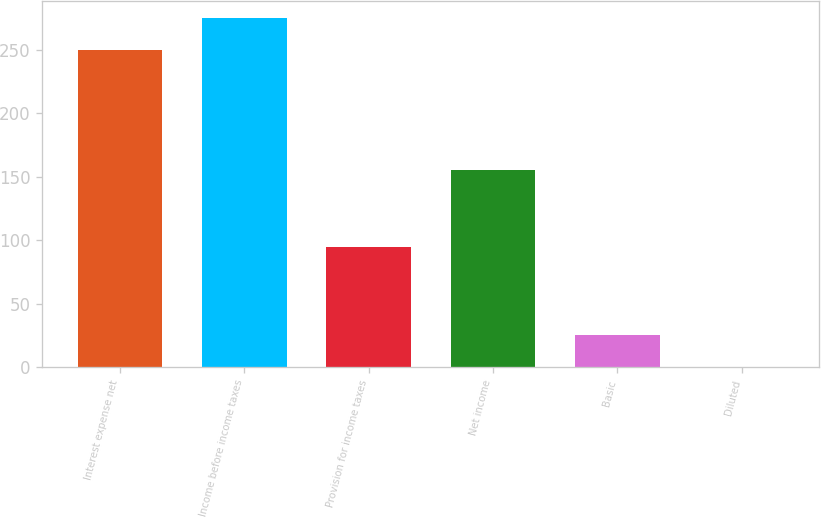Convert chart. <chart><loc_0><loc_0><loc_500><loc_500><bar_chart><fcel>Interest expense net<fcel>Income before income taxes<fcel>Provision for income taxes<fcel>Net income<fcel>Basic<fcel>Diluted<nl><fcel>250<fcel>274.99<fcel>95<fcel>155<fcel>25.13<fcel>0.15<nl></chart> 